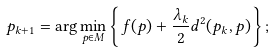<formula> <loc_0><loc_0><loc_500><loc_500>p _ { k + 1 } = \arg \min _ { p \in M } \left \{ f ( p ) + \frac { \lambda _ { k } } { 2 } d ^ { 2 } ( p _ { k } , p ) \right \} ;</formula> 